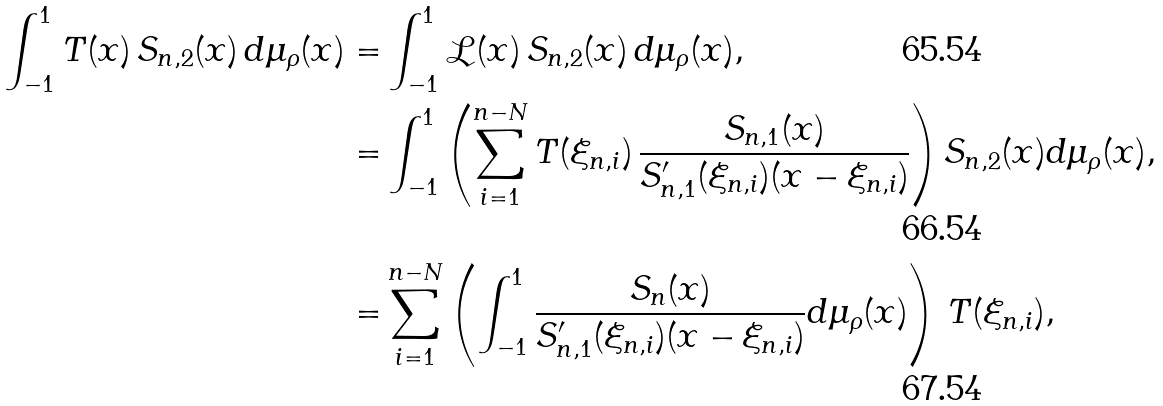<formula> <loc_0><loc_0><loc_500><loc_500>\int _ { - 1 } ^ { 1 } T ( x ) \, S _ { n , 2 } ( x ) \, d \mu _ { \rho } ( x ) = & \int _ { - 1 } ^ { 1 } \mathcal { L } ( x ) \, S _ { n , 2 } ( x ) \, d \mu _ { \rho } ( x ) , \\ = & \int _ { - 1 } ^ { 1 } \left ( \sum _ { i = 1 } ^ { n - N } T ( \xi _ { n , i } ) \, \frac { S _ { n , 1 } ( x ) } { S _ { n , 1 } ^ { \prime } ( \xi _ { n , i } ) ( x - \xi _ { n , i } ) } \right ) S _ { n , 2 } ( x ) d \mu _ { \rho } ( x ) , \\ = & \sum _ { i = 1 } ^ { n - N } \left ( \int _ { - 1 } ^ { 1 } \frac { S _ { n } ( x ) } { S ^ { \prime } _ { n , 1 } ( \xi _ { n , i } ) ( x - \xi _ { n , i } ) } d \mu _ { \rho } ( x ) \right ) \, T ( \xi _ { n , i } ) ,</formula> 